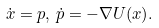Convert formula to latex. <formula><loc_0><loc_0><loc_500><loc_500>\dot { x } = p , \, \dot { p } = - \nabla U ( x ) .</formula> 